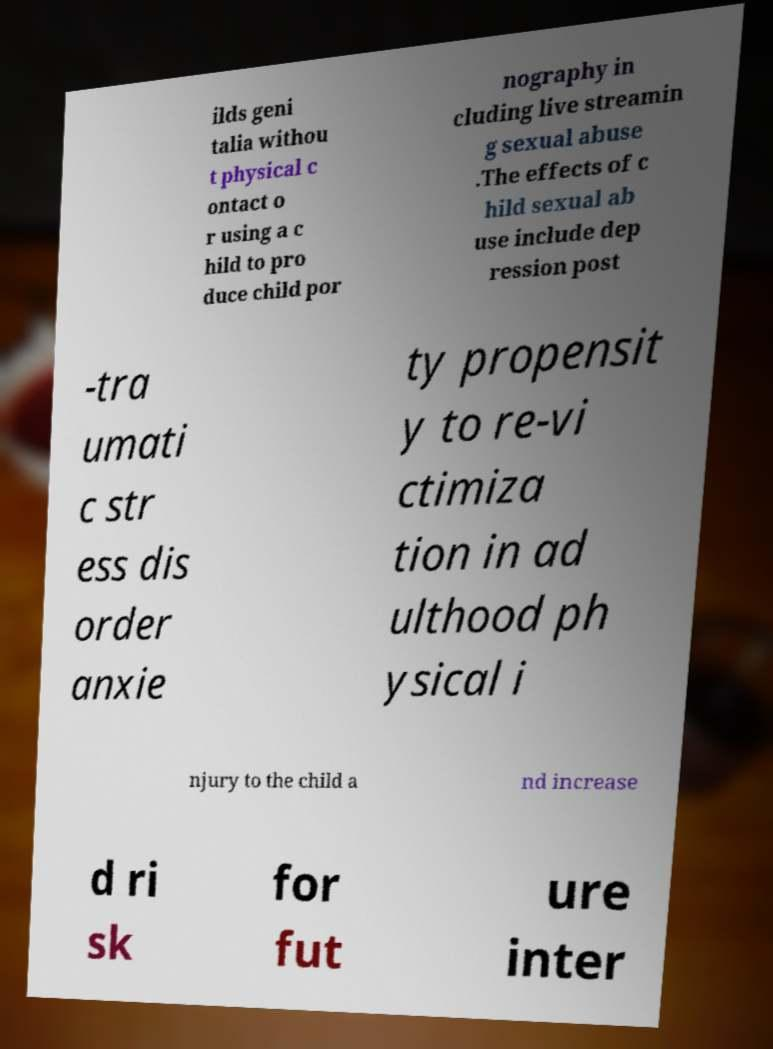Can you accurately transcribe the text from the provided image for me? ilds geni talia withou t physical c ontact o r using a c hild to pro duce child por nography in cluding live streamin g sexual abuse .The effects of c hild sexual ab use include dep ression post -tra umati c str ess dis order anxie ty propensit y to re-vi ctimiza tion in ad ulthood ph ysical i njury to the child a nd increase d ri sk for fut ure inter 